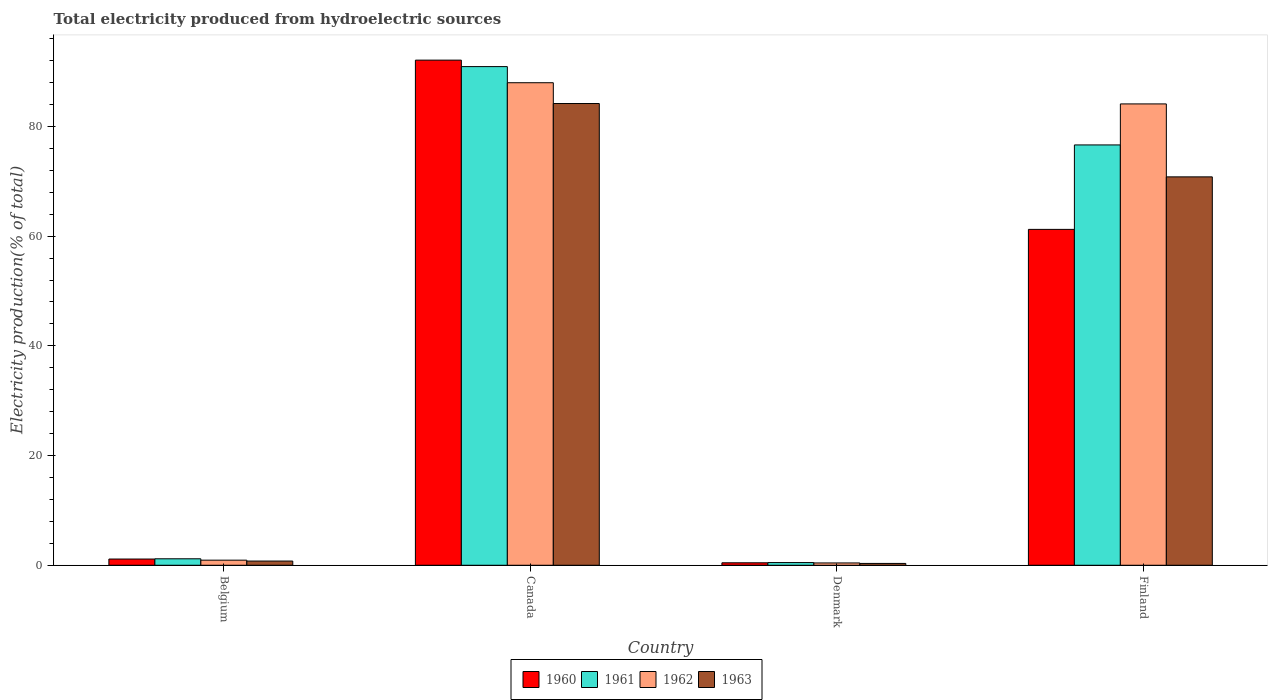How many groups of bars are there?
Offer a very short reply. 4. Are the number of bars per tick equal to the number of legend labels?
Offer a very short reply. Yes. How many bars are there on the 1st tick from the right?
Your answer should be compact. 4. In how many cases, is the number of bars for a given country not equal to the number of legend labels?
Give a very brief answer. 0. What is the total electricity produced in 1963 in Denmark?
Provide a short and direct response. 0.33. Across all countries, what is the maximum total electricity produced in 1962?
Provide a succinct answer. 87.97. Across all countries, what is the minimum total electricity produced in 1962?
Provide a short and direct response. 0.42. In which country was the total electricity produced in 1960 maximum?
Provide a short and direct response. Canada. What is the total total electricity produced in 1962 in the graph?
Keep it short and to the point. 173.43. What is the difference between the total electricity produced in 1961 in Belgium and that in Canada?
Give a very brief answer. -89.73. What is the difference between the total electricity produced in 1960 in Denmark and the total electricity produced in 1963 in Canada?
Your answer should be compact. -83.73. What is the average total electricity produced in 1963 per country?
Offer a very short reply. 39.02. What is the difference between the total electricity produced of/in 1962 and total electricity produced of/in 1961 in Finland?
Your response must be concise. 7.48. In how many countries, is the total electricity produced in 1962 greater than 36 %?
Your answer should be very brief. 2. What is the ratio of the total electricity produced in 1963 in Belgium to that in Finland?
Provide a succinct answer. 0.01. Is the total electricity produced in 1960 in Canada less than that in Finland?
Give a very brief answer. No. What is the difference between the highest and the second highest total electricity produced in 1961?
Your answer should be compact. -89.73. What is the difference between the highest and the lowest total electricity produced in 1962?
Provide a short and direct response. 87.55. Is the sum of the total electricity produced in 1962 in Belgium and Canada greater than the maximum total electricity produced in 1961 across all countries?
Your answer should be very brief. No. Is it the case that in every country, the sum of the total electricity produced in 1963 and total electricity produced in 1962 is greater than the sum of total electricity produced in 1961 and total electricity produced in 1960?
Your answer should be very brief. No. What does the 2nd bar from the left in Belgium represents?
Your answer should be very brief. 1961. What does the 1st bar from the right in Belgium represents?
Keep it short and to the point. 1963. How many bars are there?
Your response must be concise. 16. Are all the bars in the graph horizontal?
Your response must be concise. No. Does the graph contain any zero values?
Your answer should be compact. No. Does the graph contain grids?
Offer a very short reply. No. Where does the legend appear in the graph?
Your answer should be very brief. Bottom center. What is the title of the graph?
Your answer should be compact. Total electricity produced from hydroelectric sources. Does "2010" appear as one of the legend labels in the graph?
Offer a terse response. No. What is the label or title of the X-axis?
Your answer should be very brief. Country. What is the Electricity production(% of total) in 1960 in Belgium?
Your response must be concise. 1.14. What is the Electricity production(% of total) of 1961 in Belgium?
Offer a terse response. 1.18. What is the Electricity production(% of total) in 1962 in Belgium?
Ensure brevity in your answer.  0.93. What is the Electricity production(% of total) in 1963 in Belgium?
Your answer should be compact. 0.77. What is the Electricity production(% of total) of 1960 in Canada?
Your answer should be very brief. 92.09. What is the Electricity production(% of total) in 1961 in Canada?
Keep it short and to the point. 90.91. What is the Electricity production(% of total) in 1962 in Canada?
Provide a short and direct response. 87.97. What is the Electricity production(% of total) of 1963 in Canada?
Make the answer very short. 84.18. What is the Electricity production(% of total) in 1960 in Denmark?
Your answer should be very brief. 0.45. What is the Electricity production(% of total) of 1961 in Denmark?
Offer a very short reply. 0.49. What is the Electricity production(% of total) of 1962 in Denmark?
Provide a short and direct response. 0.42. What is the Electricity production(% of total) in 1963 in Denmark?
Ensure brevity in your answer.  0.33. What is the Electricity production(% of total) in 1960 in Finland?
Give a very brief answer. 61.23. What is the Electricity production(% of total) of 1961 in Finland?
Your answer should be compact. 76.63. What is the Electricity production(% of total) of 1962 in Finland?
Ensure brevity in your answer.  84.11. What is the Electricity production(% of total) of 1963 in Finland?
Your response must be concise. 70.81. Across all countries, what is the maximum Electricity production(% of total) in 1960?
Offer a very short reply. 92.09. Across all countries, what is the maximum Electricity production(% of total) in 1961?
Ensure brevity in your answer.  90.91. Across all countries, what is the maximum Electricity production(% of total) in 1962?
Your response must be concise. 87.97. Across all countries, what is the maximum Electricity production(% of total) in 1963?
Provide a succinct answer. 84.18. Across all countries, what is the minimum Electricity production(% of total) in 1960?
Provide a short and direct response. 0.45. Across all countries, what is the minimum Electricity production(% of total) of 1961?
Offer a terse response. 0.49. Across all countries, what is the minimum Electricity production(% of total) of 1962?
Ensure brevity in your answer.  0.42. Across all countries, what is the minimum Electricity production(% of total) of 1963?
Your answer should be very brief. 0.33. What is the total Electricity production(% of total) in 1960 in the graph?
Offer a very short reply. 154.91. What is the total Electricity production(% of total) of 1961 in the graph?
Offer a very short reply. 169.21. What is the total Electricity production(% of total) of 1962 in the graph?
Your response must be concise. 173.43. What is the total Electricity production(% of total) in 1963 in the graph?
Provide a succinct answer. 156.09. What is the difference between the Electricity production(% of total) of 1960 in Belgium and that in Canada?
Provide a succinct answer. -90.95. What is the difference between the Electricity production(% of total) of 1961 in Belgium and that in Canada?
Provide a succinct answer. -89.73. What is the difference between the Electricity production(% of total) in 1962 in Belgium and that in Canada?
Your answer should be very brief. -87.04. What is the difference between the Electricity production(% of total) of 1963 in Belgium and that in Canada?
Give a very brief answer. -83.41. What is the difference between the Electricity production(% of total) in 1960 in Belgium and that in Denmark?
Offer a terse response. 0.68. What is the difference between the Electricity production(% of total) of 1961 in Belgium and that in Denmark?
Keep it short and to the point. 0.69. What is the difference between the Electricity production(% of total) in 1962 in Belgium and that in Denmark?
Your answer should be very brief. 0.51. What is the difference between the Electricity production(% of total) of 1963 in Belgium and that in Denmark?
Your answer should be compact. 0.43. What is the difference between the Electricity production(% of total) in 1960 in Belgium and that in Finland?
Your answer should be compact. -60.1. What is the difference between the Electricity production(% of total) in 1961 in Belgium and that in Finland?
Your answer should be compact. -75.45. What is the difference between the Electricity production(% of total) in 1962 in Belgium and that in Finland?
Provide a short and direct response. -83.18. What is the difference between the Electricity production(% of total) of 1963 in Belgium and that in Finland?
Give a very brief answer. -70.04. What is the difference between the Electricity production(% of total) of 1960 in Canada and that in Denmark?
Make the answer very short. 91.64. What is the difference between the Electricity production(% of total) in 1961 in Canada and that in Denmark?
Keep it short and to the point. 90.42. What is the difference between the Electricity production(% of total) in 1962 in Canada and that in Denmark?
Offer a terse response. 87.55. What is the difference between the Electricity production(% of total) in 1963 in Canada and that in Denmark?
Ensure brevity in your answer.  83.84. What is the difference between the Electricity production(% of total) in 1960 in Canada and that in Finland?
Keep it short and to the point. 30.86. What is the difference between the Electricity production(% of total) of 1961 in Canada and that in Finland?
Give a very brief answer. 14.28. What is the difference between the Electricity production(% of total) of 1962 in Canada and that in Finland?
Provide a succinct answer. 3.86. What is the difference between the Electricity production(% of total) in 1963 in Canada and that in Finland?
Provide a short and direct response. 13.37. What is the difference between the Electricity production(% of total) in 1960 in Denmark and that in Finland?
Provide a succinct answer. -60.78. What is the difference between the Electricity production(% of total) in 1961 in Denmark and that in Finland?
Give a very brief answer. -76.14. What is the difference between the Electricity production(% of total) in 1962 in Denmark and that in Finland?
Your answer should be compact. -83.69. What is the difference between the Electricity production(% of total) of 1963 in Denmark and that in Finland?
Ensure brevity in your answer.  -70.47. What is the difference between the Electricity production(% of total) of 1960 in Belgium and the Electricity production(% of total) of 1961 in Canada?
Give a very brief answer. -89.78. What is the difference between the Electricity production(% of total) of 1960 in Belgium and the Electricity production(% of total) of 1962 in Canada?
Keep it short and to the point. -86.83. What is the difference between the Electricity production(% of total) of 1960 in Belgium and the Electricity production(% of total) of 1963 in Canada?
Keep it short and to the point. -83.04. What is the difference between the Electricity production(% of total) in 1961 in Belgium and the Electricity production(% of total) in 1962 in Canada?
Provide a short and direct response. -86.79. What is the difference between the Electricity production(% of total) in 1961 in Belgium and the Electricity production(% of total) in 1963 in Canada?
Ensure brevity in your answer.  -83. What is the difference between the Electricity production(% of total) in 1962 in Belgium and the Electricity production(% of total) in 1963 in Canada?
Ensure brevity in your answer.  -83.25. What is the difference between the Electricity production(% of total) of 1960 in Belgium and the Electricity production(% of total) of 1961 in Denmark?
Ensure brevity in your answer.  0.65. What is the difference between the Electricity production(% of total) of 1960 in Belgium and the Electricity production(% of total) of 1962 in Denmark?
Offer a terse response. 0.71. What is the difference between the Electricity production(% of total) of 1960 in Belgium and the Electricity production(% of total) of 1963 in Denmark?
Your answer should be compact. 0.8. What is the difference between the Electricity production(% of total) in 1961 in Belgium and the Electricity production(% of total) in 1962 in Denmark?
Make the answer very short. 0.76. What is the difference between the Electricity production(% of total) in 1961 in Belgium and the Electricity production(% of total) in 1963 in Denmark?
Provide a short and direct response. 0.84. What is the difference between the Electricity production(% of total) of 1962 in Belgium and the Electricity production(% of total) of 1963 in Denmark?
Your response must be concise. 0.59. What is the difference between the Electricity production(% of total) in 1960 in Belgium and the Electricity production(% of total) in 1961 in Finland?
Offer a very short reply. -75.49. What is the difference between the Electricity production(% of total) in 1960 in Belgium and the Electricity production(% of total) in 1962 in Finland?
Your answer should be very brief. -82.97. What is the difference between the Electricity production(% of total) in 1960 in Belgium and the Electricity production(% of total) in 1963 in Finland?
Ensure brevity in your answer.  -69.67. What is the difference between the Electricity production(% of total) in 1961 in Belgium and the Electricity production(% of total) in 1962 in Finland?
Make the answer very short. -82.93. What is the difference between the Electricity production(% of total) in 1961 in Belgium and the Electricity production(% of total) in 1963 in Finland?
Ensure brevity in your answer.  -69.63. What is the difference between the Electricity production(% of total) of 1962 in Belgium and the Electricity production(% of total) of 1963 in Finland?
Offer a terse response. -69.88. What is the difference between the Electricity production(% of total) of 1960 in Canada and the Electricity production(% of total) of 1961 in Denmark?
Give a very brief answer. 91.6. What is the difference between the Electricity production(% of total) in 1960 in Canada and the Electricity production(% of total) in 1962 in Denmark?
Ensure brevity in your answer.  91.67. What is the difference between the Electricity production(% of total) in 1960 in Canada and the Electricity production(% of total) in 1963 in Denmark?
Your answer should be very brief. 91.75. What is the difference between the Electricity production(% of total) in 1961 in Canada and the Electricity production(% of total) in 1962 in Denmark?
Offer a very short reply. 90.49. What is the difference between the Electricity production(% of total) of 1961 in Canada and the Electricity production(% of total) of 1963 in Denmark?
Offer a terse response. 90.58. What is the difference between the Electricity production(% of total) of 1962 in Canada and the Electricity production(% of total) of 1963 in Denmark?
Your answer should be very brief. 87.63. What is the difference between the Electricity production(% of total) of 1960 in Canada and the Electricity production(% of total) of 1961 in Finland?
Make the answer very short. 15.46. What is the difference between the Electricity production(% of total) in 1960 in Canada and the Electricity production(% of total) in 1962 in Finland?
Provide a succinct answer. 7.98. What is the difference between the Electricity production(% of total) of 1960 in Canada and the Electricity production(% of total) of 1963 in Finland?
Provide a succinct answer. 21.28. What is the difference between the Electricity production(% of total) in 1961 in Canada and the Electricity production(% of total) in 1962 in Finland?
Keep it short and to the point. 6.8. What is the difference between the Electricity production(% of total) in 1961 in Canada and the Electricity production(% of total) in 1963 in Finland?
Provide a succinct answer. 20.1. What is the difference between the Electricity production(% of total) in 1962 in Canada and the Electricity production(% of total) in 1963 in Finland?
Offer a terse response. 17.16. What is the difference between the Electricity production(% of total) in 1960 in Denmark and the Electricity production(% of total) in 1961 in Finland?
Provide a succinct answer. -76.18. What is the difference between the Electricity production(% of total) of 1960 in Denmark and the Electricity production(% of total) of 1962 in Finland?
Your answer should be compact. -83.66. What is the difference between the Electricity production(% of total) of 1960 in Denmark and the Electricity production(% of total) of 1963 in Finland?
Offer a terse response. -70.36. What is the difference between the Electricity production(% of total) in 1961 in Denmark and the Electricity production(% of total) in 1962 in Finland?
Your response must be concise. -83.62. What is the difference between the Electricity production(% of total) in 1961 in Denmark and the Electricity production(% of total) in 1963 in Finland?
Your answer should be compact. -70.32. What is the difference between the Electricity production(% of total) of 1962 in Denmark and the Electricity production(% of total) of 1963 in Finland?
Offer a terse response. -70.39. What is the average Electricity production(% of total) of 1960 per country?
Give a very brief answer. 38.73. What is the average Electricity production(% of total) in 1961 per country?
Provide a succinct answer. 42.3. What is the average Electricity production(% of total) of 1962 per country?
Provide a succinct answer. 43.36. What is the average Electricity production(% of total) in 1963 per country?
Give a very brief answer. 39.02. What is the difference between the Electricity production(% of total) in 1960 and Electricity production(% of total) in 1961 in Belgium?
Ensure brevity in your answer.  -0.04. What is the difference between the Electricity production(% of total) of 1960 and Electricity production(% of total) of 1962 in Belgium?
Your answer should be very brief. 0.21. What is the difference between the Electricity production(% of total) of 1960 and Electricity production(% of total) of 1963 in Belgium?
Keep it short and to the point. 0.37. What is the difference between the Electricity production(% of total) of 1961 and Electricity production(% of total) of 1962 in Belgium?
Your answer should be very brief. 0.25. What is the difference between the Electricity production(% of total) of 1961 and Electricity production(% of total) of 1963 in Belgium?
Keep it short and to the point. 0.41. What is the difference between the Electricity production(% of total) of 1962 and Electricity production(% of total) of 1963 in Belgium?
Offer a terse response. 0.16. What is the difference between the Electricity production(% of total) in 1960 and Electricity production(% of total) in 1961 in Canada?
Your response must be concise. 1.18. What is the difference between the Electricity production(% of total) in 1960 and Electricity production(% of total) in 1962 in Canada?
Give a very brief answer. 4.12. What is the difference between the Electricity production(% of total) of 1960 and Electricity production(% of total) of 1963 in Canada?
Provide a succinct answer. 7.91. What is the difference between the Electricity production(% of total) of 1961 and Electricity production(% of total) of 1962 in Canada?
Offer a very short reply. 2.94. What is the difference between the Electricity production(% of total) of 1961 and Electricity production(% of total) of 1963 in Canada?
Provide a succinct answer. 6.73. What is the difference between the Electricity production(% of total) of 1962 and Electricity production(% of total) of 1963 in Canada?
Provide a short and direct response. 3.79. What is the difference between the Electricity production(% of total) in 1960 and Electricity production(% of total) in 1961 in Denmark?
Keep it short and to the point. -0.04. What is the difference between the Electricity production(% of total) of 1960 and Electricity production(% of total) of 1962 in Denmark?
Make the answer very short. 0.03. What is the difference between the Electricity production(% of total) in 1960 and Electricity production(% of total) in 1963 in Denmark?
Provide a short and direct response. 0.12. What is the difference between the Electricity production(% of total) of 1961 and Electricity production(% of total) of 1962 in Denmark?
Provide a short and direct response. 0.07. What is the difference between the Electricity production(% of total) in 1961 and Electricity production(% of total) in 1963 in Denmark?
Make the answer very short. 0.15. What is the difference between the Electricity production(% of total) of 1962 and Electricity production(% of total) of 1963 in Denmark?
Your answer should be very brief. 0.09. What is the difference between the Electricity production(% of total) in 1960 and Electricity production(% of total) in 1961 in Finland?
Your answer should be compact. -15.4. What is the difference between the Electricity production(% of total) in 1960 and Electricity production(% of total) in 1962 in Finland?
Provide a succinct answer. -22.88. What is the difference between the Electricity production(% of total) of 1960 and Electricity production(% of total) of 1963 in Finland?
Your answer should be very brief. -9.58. What is the difference between the Electricity production(% of total) of 1961 and Electricity production(% of total) of 1962 in Finland?
Give a very brief answer. -7.48. What is the difference between the Electricity production(% of total) in 1961 and Electricity production(% of total) in 1963 in Finland?
Your answer should be very brief. 5.82. What is the difference between the Electricity production(% of total) of 1962 and Electricity production(% of total) of 1963 in Finland?
Offer a very short reply. 13.3. What is the ratio of the Electricity production(% of total) in 1960 in Belgium to that in Canada?
Offer a terse response. 0.01. What is the ratio of the Electricity production(% of total) in 1961 in Belgium to that in Canada?
Keep it short and to the point. 0.01. What is the ratio of the Electricity production(% of total) in 1962 in Belgium to that in Canada?
Offer a very short reply. 0.01. What is the ratio of the Electricity production(% of total) in 1963 in Belgium to that in Canada?
Your response must be concise. 0.01. What is the ratio of the Electricity production(% of total) of 1960 in Belgium to that in Denmark?
Provide a succinct answer. 2.52. What is the ratio of the Electricity production(% of total) of 1961 in Belgium to that in Denmark?
Your answer should be very brief. 2.41. What is the ratio of the Electricity production(% of total) of 1962 in Belgium to that in Denmark?
Offer a very short reply. 2.21. What is the ratio of the Electricity production(% of total) of 1963 in Belgium to that in Denmark?
Ensure brevity in your answer.  2.29. What is the ratio of the Electricity production(% of total) in 1960 in Belgium to that in Finland?
Your answer should be compact. 0.02. What is the ratio of the Electricity production(% of total) in 1961 in Belgium to that in Finland?
Ensure brevity in your answer.  0.02. What is the ratio of the Electricity production(% of total) in 1962 in Belgium to that in Finland?
Ensure brevity in your answer.  0.01. What is the ratio of the Electricity production(% of total) of 1963 in Belgium to that in Finland?
Your response must be concise. 0.01. What is the ratio of the Electricity production(% of total) of 1960 in Canada to that in Denmark?
Keep it short and to the point. 204.07. What is the ratio of the Electricity production(% of total) in 1961 in Canada to that in Denmark?
Give a very brief answer. 185.88. What is the ratio of the Electricity production(% of total) of 1962 in Canada to that in Denmark?
Provide a succinct answer. 208.99. What is the ratio of the Electricity production(% of total) of 1963 in Canada to that in Denmark?
Keep it short and to the point. 251.69. What is the ratio of the Electricity production(% of total) in 1960 in Canada to that in Finland?
Keep it short and to the point. 1.5. What is the ratio of the Electricity production(% of total) in 1961 in Canada to that in Finland?
Your answer should be very brief. 1.19. What is the ratio of the Electricity production(% of total) of 1962 in Canada to that in Finland?
Provide a short and direct response. 1.05. What is the ratio of the Electricity production(% of total) of 1963 in Canada to that in Finland?
Give a very brief answer. 1.19. What is the ratio of the Electricity production(% of total) in 1960 in Denmark to that in Finland?
Keep it short and to the point. 0.01. What is the ratio of the Electricity production(% of total) of 1961 in Denmark to that in Finland?
Offer a terse response. 0.01. What is the ratio of the Electricity production(% of total) in 1962 in Denmark to that in Finland?
Your answer should be compact. 0.01. What is the ratio of the Electricity production(% of total) in 1963 in Denmark to that in Finland?
Ensure brevity in your answer.  0. What is the difference between the highest and the second highest Electricity production(% of total) in 1960?
Offer a very short reply. 30.86. What is the difference between the highest and the second highest Electricity production(% of total) of 1961?
Your answer should be very brief. 14.28. What is the difference between the highest and the second highest Electricity production(% of total) in 1962?
Keep it short and to the point. 3.86. What is the difference between the highest and the second highest Electricity production(% of total) in 1963?
Give a very brief answer. 13.37. What is the difference between the highest and the lowest Electricity production(% of total) of 1960?
Provide a short and direct response. 91.64. What is the difference between the highest and the lowest Electricity production(% of total) in 1961?
Make the answer very short. 90.42. What is the difference between the highest and the lowest Electricity production(% of total) of 1962?
Offer a very short reply. 87.55. What is the difference between the highest and the lowest Electricity production(% of total) of 1963?
Your response must be concise. 83.84. 